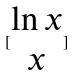<formula> <loc_0><loc_0><loc_500><loc_500>[ \begin{matrix} \ln x \\ x \end{matrix} ]</formula> 